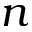<formula> <loc_0><loc_0><loc_500><loc_500>n</formula> 